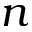<formula> <loc_0><loc_0><loc_500><loc_500>n</formula> 